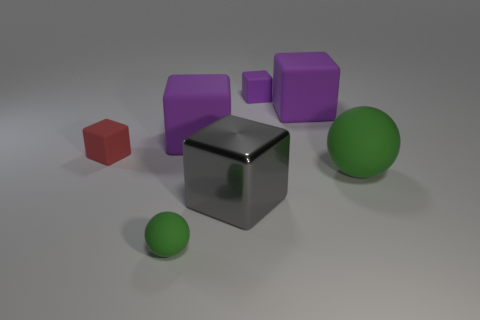What can you infer about the setting of this image? The image seems to be set in a controlled environment, such as a studio, where objects are arranged for the purpose of a composition or a test render. The plain background and floor, along with the organized positioning of the objects, suggest that the focus is on the objects themselves rather than their context or background story. 